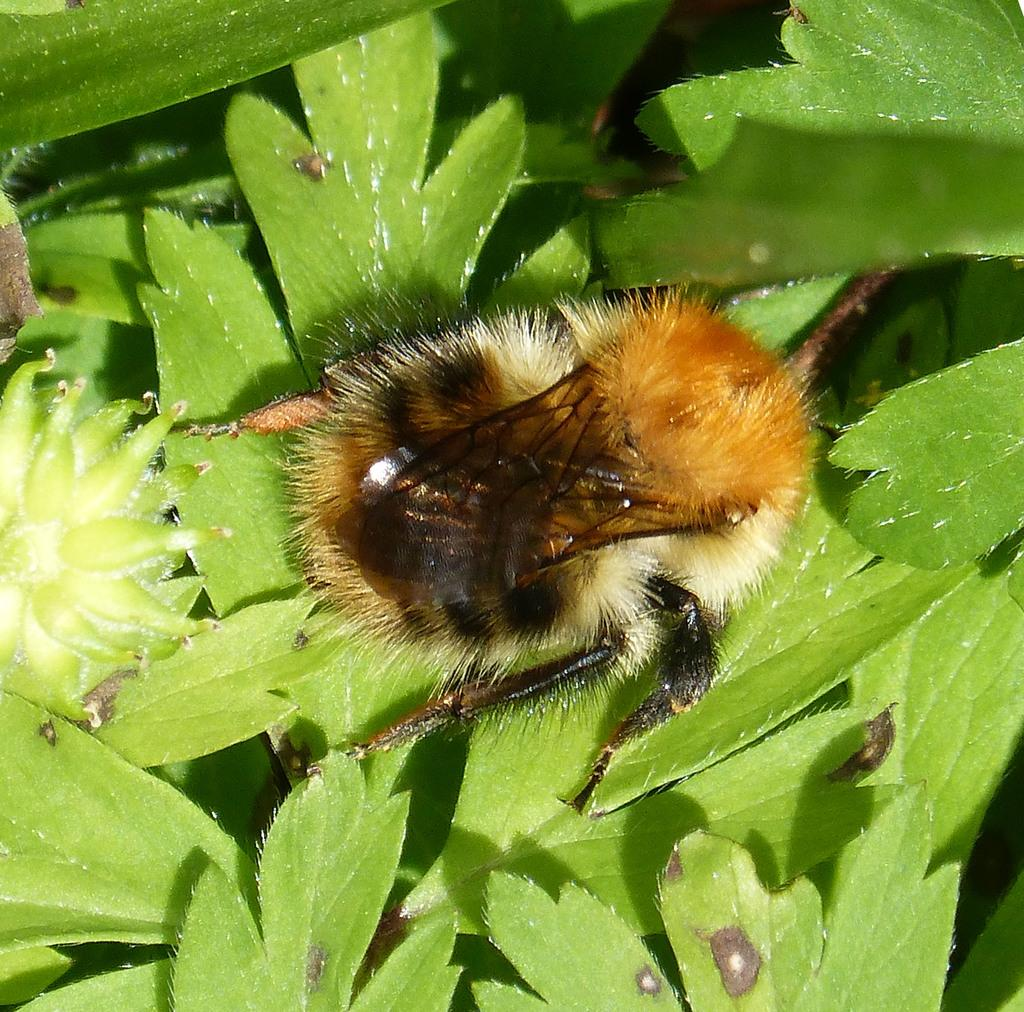What is the main subject in the center of the image? There is a bee in the center of the image. What type of vegetation can be seen at the bottom of the image? There are leaves at the bottom of the image. What language is the bee speaking in the image? Bees do not speak human languages, so there is no language spoken by the bee in the image. 